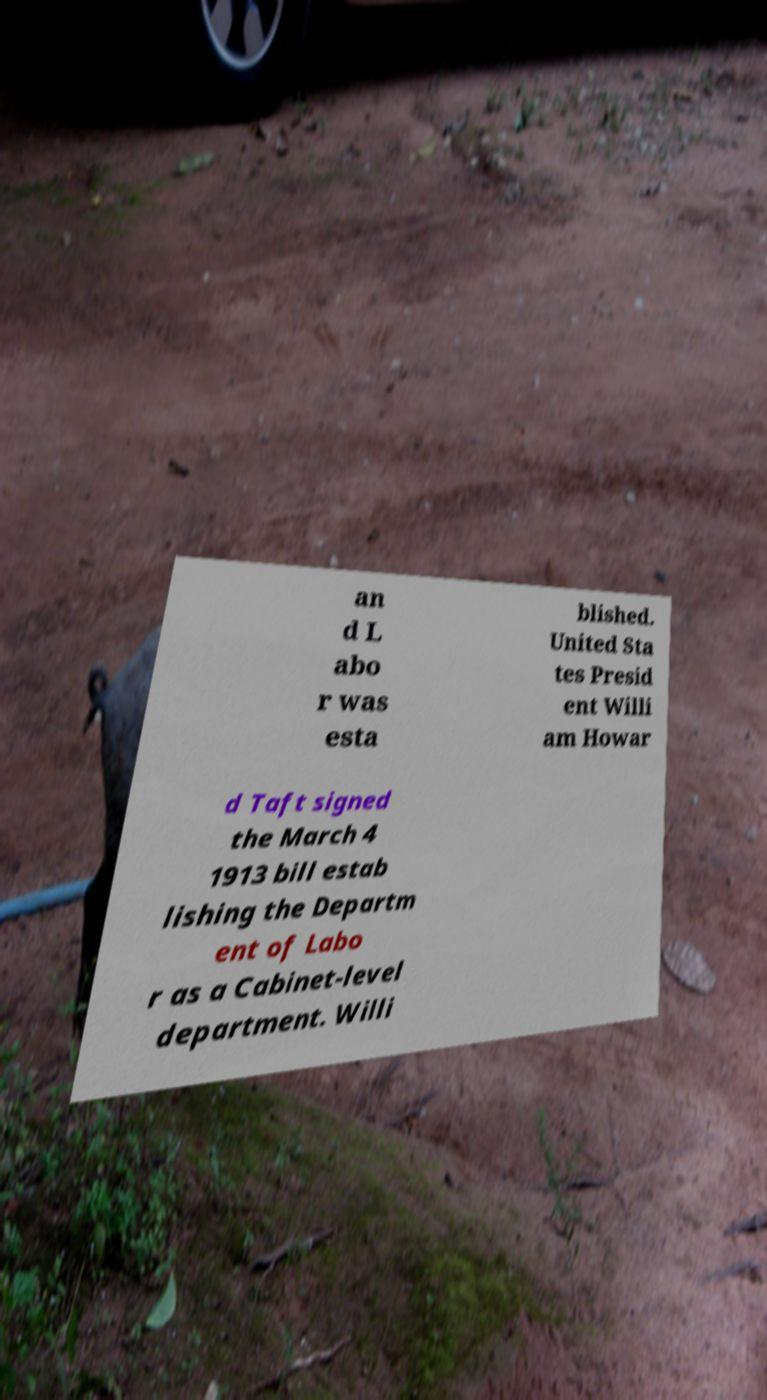For documentation purposes, I need the text within this image transcribed. Could you provide that? an d L abo r was esta blished. United Sta tes Presid ent Willi am Howar d Taft signed the March 4 1913 bill estab lishing the Departm ent of Labo r as a Cabinet-level department. Willi 